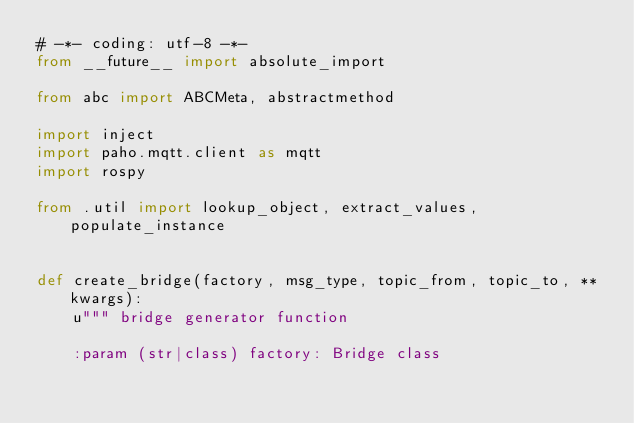<code> <loc_0><loc_0><loc_500><loc_500><_Python_># -*- coding: utf-8 -*-
from __future__ import absolute_import

from abc import ABCMeta, abstractmethod

import inject
import paho.mqtt.client as mqtt
import rospy

from .util import lookup_object, extract_values, populate_instance


def create_bridge(factory, msg_type, topic_from, topic_to, **kwargs):
    u""" bridge generator function

    :param (str|class) factory: Bridge class</code> 